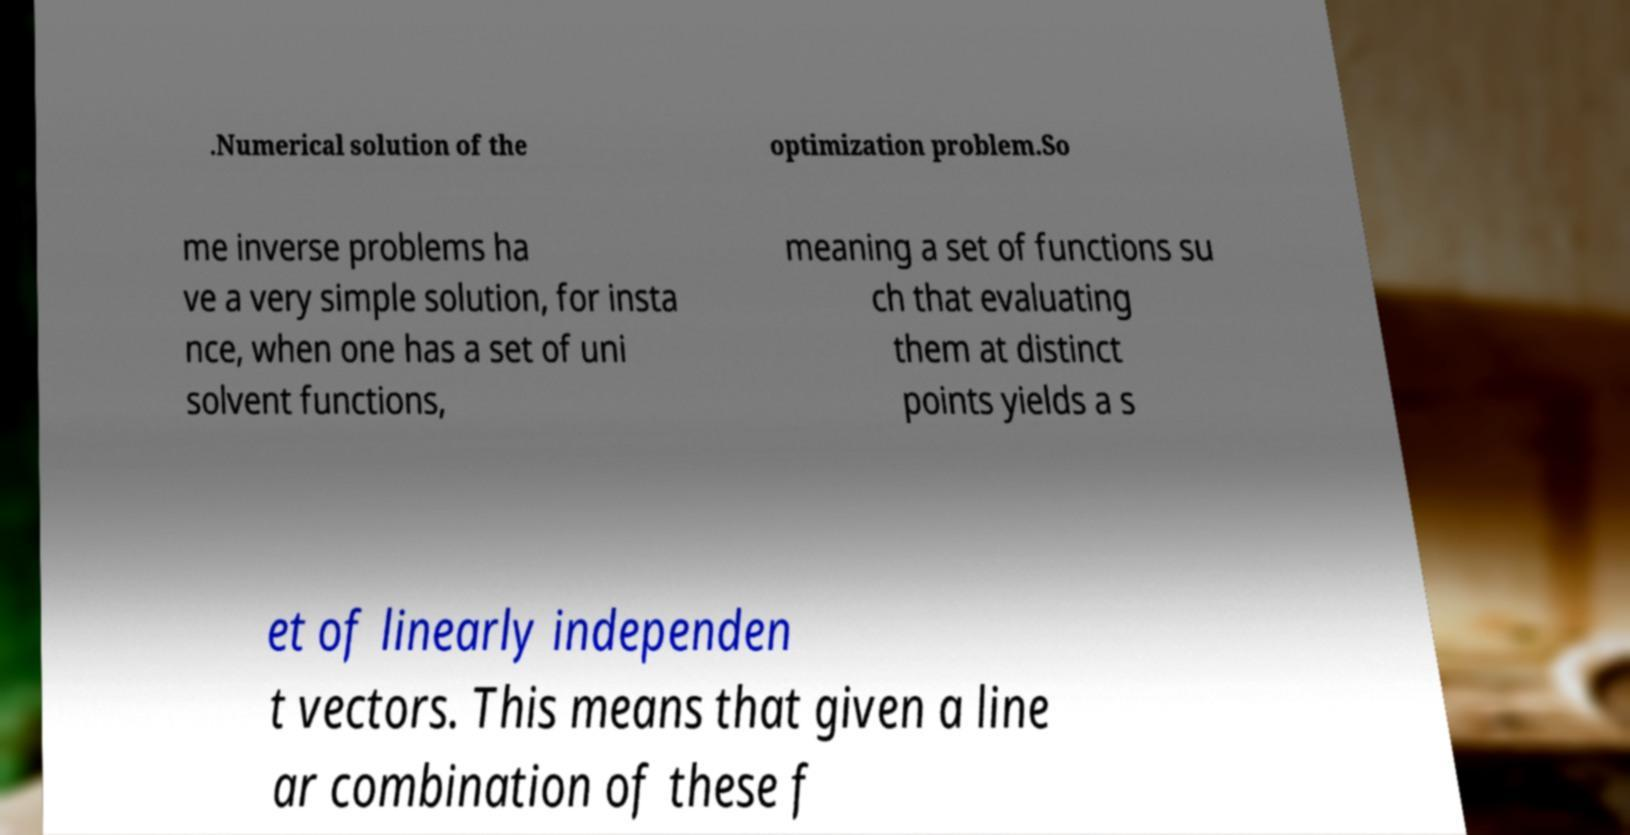There's text embedded in this image that I need extracted. Can you transcribe it verbatim? .Numerical solution of the optimization problem.So me inverse problems ha ve a very simple solution, for insta nce, when one has a set of uni solvent functions, meaning a set of functions su ch that evaluating them at distinct points yields a s et of linearly independen t vectors. This means that given a line ar combination of these f 